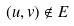Convert formula to latex. <formula><loc_0><loc_0><loc_500><loc_500>( u , v ) \notin E</formula> 